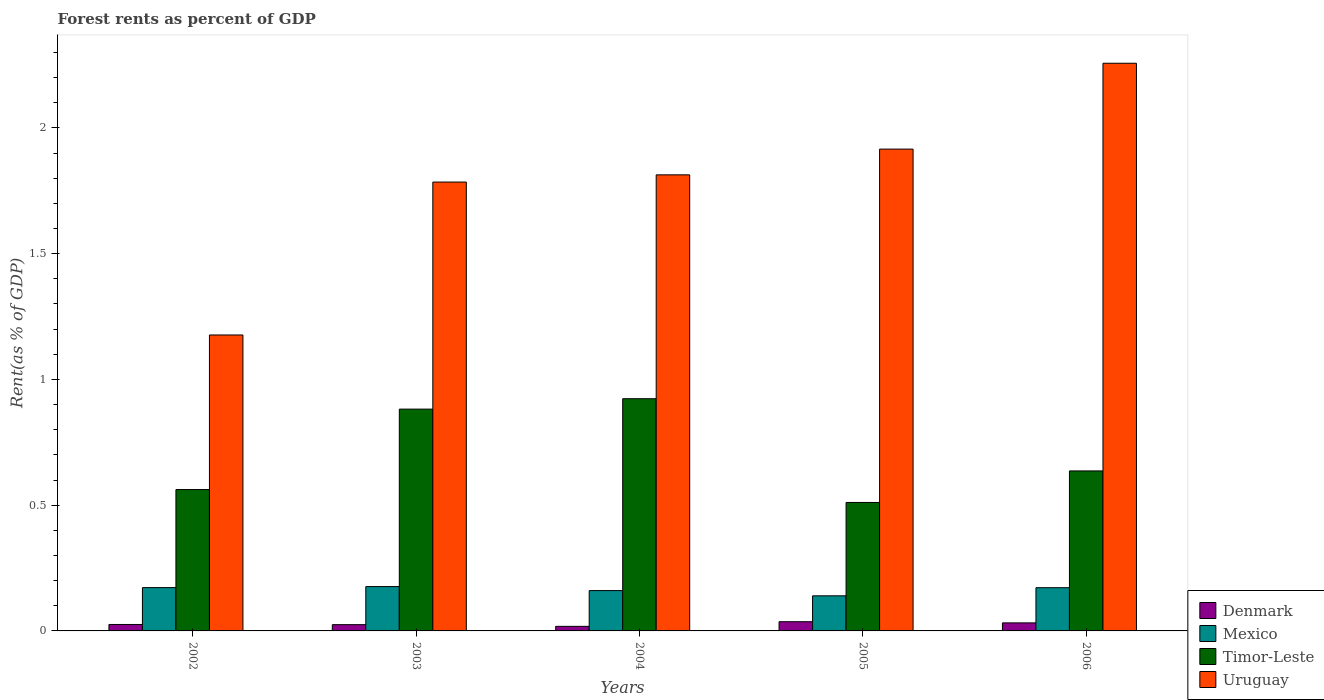How many bars are there on the 3rd tick from the left?
Give a very brief answer. 4. In how many cases, is the number of bars for a given year not equal to the number of legend labels?
Provide a short and direct response. 0. What is the forest rent in Denmark in 2004?
Offer a terse response. 0.02. Across all years, what is the maximum forest rent in Mexico?
Your answer should be very brief. 0.18. Across all years, what is the minimum forest rent in Timor-Leste?
Your answer should be compact. 0.51. In which year was the forest rent in Mexico maximum?
Offer a terse response. 2003. In which year was the forest rent in Denmark minimum?
Your answer should be compact. 2004. What is the total forest rent in Mexico in the graph?
Keep it short and to the point. 0.82. What is the difference between the forest rent in Mexico in 2004 and that in 2006?
Give a very brief answer. -0.01. What is the difference between the forest rent in Denmark in 2002 and the forest rent in Uruguay in 2004?
Make the answer very short. -1.79. What is the average forest rent in Mexico per year?
Give a very brief answer. 0.16. In the year 2006, what is the difference between the forest rent in Denmark and forest rent in Timor-Leste?
Provide a succinct answer. -0.6. What is the ratio of the forest rent in Mexico in 2003 to that in 2005?
Provide a short and direct response. 1.26. Is the forest rent in Timor-Leste in 2003 less than that in 2006?
Provide a succinct answer. No. Is the difference between the forest rent in Denmark in 2002 and 2005 greater than the difference between the forest rent in Timor-Leste in 2002 and 2005?
Your answer should be very brief. No. What is the difference between the highest and the second highest forest rent in Denmark?
Your answer should be compact. 0. What is the difference between the highest and the lowest forest rent in Mexico?
Your answer should be compact. 0.04. Is it the case that in every year, the sum of the forest rent in Timor-Leste and forest rent in Uruguay is greater than the sum of forest rent in Denmark and forest rent in Mexico?
Offer a terse response. Yes. What does the 1st bar from the left in 2004 represents?
Offer a very short reply. Denmark. What does the 2nd bar from the right in 2004 represents?
Ensure brevity in your answer.  Timor-Leste. How many bars are there?
Make the answer very short. 20. What is the difference between two consecutive major ticks on the Y-axis?
Make the answer very short. 0.5. Does the graph contain any zero values?
Provide a succinct answer. No. Where does the legend appear in the graph?
Your response must be concise. Bottom right. How are the legend labels stacked?
Offer a terse response. Vertical. What is the title of the graph?
Your response must be concise. Forest rents as percent of GDP. Does "Malawi" appear as one of the legend labels in the graph?
Give a very brief answer. No. What is the label or title of the Y-axis?
Your answer should be compact. Rent(as % of GDP). What is the Rent(as % of GDP) in Denmark in 2002?
Provide a succinct answer. 0.03. What is the Rent(as % of GDP) in Mexico in 2002?
Ensure brevity in your answer.  0.17. What is the Rent(as % of GDP) in Timor-Leste in 2002?
Provide a succinct answer. 0.56. What is the Rent(as % of GDP) in Uruguay in 2002?
Your answer should be very brief. 1.18. What is the Rent(as % of GDP) in Denmark in 2003?
Keep it short and to the point. 0.02. What is the Rent(as % of GDP) of Mexico in 2003?
Keep it short and to the point. 0.18. What is the Rent(as % of GDP) in Timor-Leste in 2003?
Your answer should be compact. 0.88. What is the Rent(as % of GDP) in Uruguay in 2003?
Give a very brief answer. 1.78. What is the Rent(as % of GDP) of Denmark in 2004?
Ensure brevity in your answer.  0.02. What is the Rent(as % of GDP) in Mexico in 2004?
Keep it short and to the point. 0.16. What is the Rent(as % of GDP) in Timor-Leste in 2004?
Keep it short and to the point. 0.92. What is the Rent(as % of GDP) of Uruguay in 2004?
Provide a succinct answer. 1.81. What is the Rent(as % of GDP) of Denmark in 2005?
Keep it short and to the point. 0.04. What is the Rent(as % of GDP) of Mexico in 2005?
Provide a short and direct response. 0.14. What is the Rent(as % of GDP) in Timor-Leste in 2005?
Give a very brief answer. 0.51. What is the Rent(as % of GDP) in Uruguay in 2005?
Offer a very short reply. 1.92. What is the Rent(as % of GDP) of Denmark in 2006?
Ensure brevity in your answer.  0.03. What is the Rent(as % of GDP) in Mexico in 2006?
Make the answer very short. 0.17. What is the Rent(as % of GDP) of Timor-Leste in 2006?
Your response must be concise. 0.64. What is the Rent(as % of GDP) in Uruguay in 2006?
Offer a very short reply. 2.26. Across all years, what is the maximum Rent(as % of GDP) in Denmark?
Ensure brevity in your answer.  0.04. Across all years, what is the maximum Rent(as % of GDP) in Mexico?
Offer a terse response. 0.18. Across all years, what is the maximum Rent(as % of GDP) in Timor-Leste?
Your answer should be very brief. 0.92. Across all years, what is the maximum Rent(as % of GDP) of Uruguay?
Give a very brief answer. 2.26. Across all years, what is the minimum Rent(as % of GDP) of Denmark?
Ensure brevity in your answer.  0.02. Across all years, what is the minimum Rent(as % of GDP) of Mexico?
Give a very brief answer. 0.14. Across all years, what is the minimum Rent(as % of GDP) in Timor-Leste?
Offer a very short reply. 0.51. Across all years, what is the minimum Rent(as % of GDP) of Uruguay?
Ensure brevity in your answer.  1.18. What is the total Rent(as % of GDP) of Denmark in the graph?
Offer a terse response. 0.14. What is the total Rent(as % of GDP) of Mexico in the graph?
Give a very brief answer. 0.82. What is the total Rent(as % of GDP) in Timor-Leste in the graph?
Give a very brief answer. 3.51. What is the total Rent(as % of GDP) in Uruguay in the graph?
Offer a very short reply. 8.95. What is the difference between the Rent(as % of GDP) of Denmark in 2002 and that in 2003?
Provide a short and direct response. 0. What is the difference between the Rent(as % of GDP) in Mexico in 2002 and that in 2003?
Ensure brevity in your answer.  -0. What is the difference between the Rent(as % of GDP) of Timor-Leste in 2002 and that in 2003?
Keep it short and to the point. -0.32. What is the difference between the Rent(as % of GDP) in Uruguay in 2002 and that in 2003?
Ensure brevity in your answer.  -0.61. What is the difference between the Rent(as % of GDP) of Denmark in 2002 and that in 2004?
Ensure brevity in your answer.  0.01. What is the difference between the Rent(as % of GDP) in Mexico in 2002 and that in 2004?
Your answer should be very brief. 0.01. What is the difference between the Rent(as % of GDP) of Timor-Leste in 2002 and that in 2004?
Ensure brevity in your answer.  -0.36. What is the difference between the Rent(as % of GDP) of Uruguay in 2002 and that in 2004?
Offer a very short reply. -0.64. What is the difference between the Rent(as % of GDP) in Denmark in 2002 and that in 2005?
Your response must be concise. -0.01. What is the difference between the Rent(as % of GDP) of Mexico in 2002 and that in 2005?
Offer a terse response. 0.03. What is the difference between the Rent(as % of GDP) of Timor-Leste in 2002 and that in 2005?
Make the answer very short. 0.05. What is the difference between the Rent(as % of GDP) of Uruguay in 2002 and that in 2005?
Offer a terse response. -0.74. What is the difference between the Rent(as % of GDP) of Denmark in 2002 and that in 2006?
Provide a succinct answer. -0.01. What is the difference between the Rent(as % of GDP) of Mexico in 2002 and that in 2006?
Provide a succinct answer. 0. What is the difference between the Rent(as % of GDP) in Timor-Leste in 2002 and that in 2006?
Your response must be concise. -0.07. What is the difference between the Rent(as % of GDP) of Uruguay in 2002 and that in 2006?
Offer a terse response. -1.08. What is the difference between the Rent(as % of GDP) of Denmark in 2003 and that in 2004?
Provide a short and direct response. 0.01. What is the difference between the Rent(as % of GDP) in Mexico in 2003 and that in 2004?
Provide a short and direct response. 0.02. What is the difference between the Rent(as % of GDP) of Timor-Leste in 2003 and that in 2004?
Your response must be concise. -0.04. What is the difference between the Rent(as % of GDP) of Uruguay in 2003 and that in 2004?
Provide a short and direct response. -0.03. What is the difference between the Rent(as % of GDP) of Denmark in 2003 and that in 2005?
Provide a succinct answer. -0.01. What is the difference between the Rent(as % of GDP) of Mexico in 2003 and that in 2005?
Offer a very short reply. 0.04. What is the difference between the Rent(as % of GDP) of Timor-Leste in 2003 and that in 2005?
Your response must be concise. 0.37. What is the difference between the Rent(as % of GDP) of Uruguay in 2003 and that in 2005?
Make the answer very short. -0.13. What is the difference between the Rent(as % of GDP) in Denmark in 2003 and that in 2006?
Offer a terse response. -0.01. What is the difference between the Rent(as % of GDP) in Mexico in 2003 and that in 2006?
Give a very brief answer. 0. What is the difference between the Rent(as % of GDP) of Timor-Leste in 2003 and that in 2006?
Your response must be concise. 0.25. What is the difference between the Rent(as % of GDP) of Uruguay in 2003 and that in 2006?
Provide a succinct answer. -0.47. What is the difference between the Rent(as % of GDP) of Denmark in 2004 and that in 2005?
Ensure brevity in your answer.  -0.02. What is the difference between the Rent(as % of GDP) of Mexico in 2004 and that in 2005?
Provide a short and direct response. 0.02. What is the difference between the Rent(as % of GDP) of Timor-Leste in 2004 and that in 2005?
Offer a very short reply. 0.41. What is the difference between the Rent(as % of GDP) of Uruguay in 2004 and that in 2005?
Offer a terse response. -0.1. What is the difference between the Rent(as % of GDP) of Denmark in 2004 and that in 2006?
Your answer should be compact. -0.01. What is the difference between the Rent(as % of GDP) in Mexico in 2004 and that in 2006?
Ensure brevity in your answer.  -0.01. What is the difference between the Rent(as % of GDP) in Timor-Leste in 2004 and that in 2006?
Give a very brief answer. 0.29. What is the difference between the Rent(as % of GDP) in Uruguay in 2004 and that in 2006?
Keep it short and to the point. -0.44. What is the difference between the Rent(as % of GDP) in Denmark in 2005 and that in 2006?
Offer a very short reply. 0. What is the difference between the Rent(as % of GDP) of Mexico in 2005 and that in 2006?
Offer a terse response. -0.03. What is the difference between the Rent(as % of GDP) of Timor-Leste in 2005 and that in 2006?
Your answer should be compact. -0.13. What is the difference between the Rent(as % of GDP) of Uruguay in 2005 and that in 2006?
Provide a succinct answer. -0.34. What is the difference between the Rent(as % of GDP) in Denmark in 2002 and the Rent(as % of GDP) in Mexico in 2003?
Ensure brevity in your answer.  -0.15. What is the difference between the Rent(as % of GDP) of Denmark in 2002 and the Rent(as % of GDP) of Timor-Leste in 2003?
Your answer should be very brief. -0.86. What is the difference between the Rent(as % of GDP) in Denmark in 2002 and the Rent(as % of GDP) in Uruguay in 2003?
Offer a terse response. -1.76. What is the difference between the Rent(as % of GDP) in Mexico in 2002 and the Rent(as % of GDP) in Timor-Leste in 2003?
Provide a short and direct response. -0.71. What is the difference between the Rent(as % of GDP) of Mexico in 2002 and the Rent(as % of GDP) of Uruguay in 2003?
Give a very brief answer. -1.61. What is the difference between the Rent(as % of GDP) of Timor-Leste in 2002 and the Rent(as % of GDP) of Uruguay in 2003?
Provide a short and direct response. -1.22. What is the difference between the Rent(as % of GDP) in Denmark in 2002 and the Rent(as % of GDP) in Mexico in 2004?
Your response must be concise. -0.13. What is the difference between the Rent(as % of GDP) of Denmark in 2002 and the Rent(as % of GDP) of Timor-Leste in 2004?
Offer a very short reply. -0.9. What is the difference between the Rent(as % of GDP) of Denmark in 2002 and the Rent(as % of GDP) of Uruguay in 2004?
Make the answer very short. -1.79. What is the difference between the Rent(as % of GDP) in Mexico in 2002 and the Rent(as % of GDP) in Timor-Leste in 2004?
Keep it short and to the point. -0.75. What is the difference between the Rent(as % of GDP) of Mexico in 2002 and the Rent(as % of GDP) of Uruguay in 2004?
Offer a very short reply. -1.64. What is the difference between the Rent(as % of GDP) in Timor-Leste in 2002 and the Rent(as % of GDP) in Uruguay in 2004?
Provide a short and direct response. -1.25. What is the difference between the Rent(as % of GDP) in Denmark in 2002 and the Rent(as % of GDP) in Mexico in 2005?
Your answer should be compact. -0.11. What is the difference between the Rent(as % of GDP) in Denmark in 2002 and the Rent(as % of GDP) in Timor-Leste in 2005?
Offer a very short reply. -0.49. What is the difference between the Rent(as % of GDP) of Denmark in 2002 and the Rent(as % of GDP) of Uruguay in 2005?
Ensure brevity in your answer.  -1.89. What is the difference between the Rent(as % of GDP) in Mexico in 2002 and the Rent(as % of GDP) in Timor-Leste in 2005?
Provide a succinct answer. -0.34. What is the difference between the Rent(as % of GDP) in Mexico in 2002 and the Rent(as % of GDP) in Uruguay in 2005?
Give a very brief answer. -1.74. What is the difference between the Rent(as % of GDP) of Timor-Leste in 2002 and the Rent(as % of GDP) of Uruguay in 2005?
Offer a terse response. -1.35. What is the difference between the Rent(as % of GDP) in Denmark in 2002 and the Rent(as % of GDP) in Mexico in 2006?
Offer a very short reply. -0.15. What is the difference between the Rent(as % of GDP) of Denmark in 2002 and the Rent(as % of GDP) of Timor-Leste in 2006?
Your answer should be very brief. -0.61. What is the difference between the Rent(as % of GDP) of Denmark in 2002 and the Rent(as % of GDP) of Uruguay in 2006?
Give a very brief answer. -2.23. What is the difference between the Rent(as % of GDP) of Mexico in 2002 and the Rent(as % of GDP) of Timor-Leste in 2006?
Give a very brief answer. -0.46. What is the difference between the Rent(as % of GDP) in Mexico in 2002 and the Rent(as % of GDP) in Uruguay in 2006?
Ensure brevity in your answer.  -2.08. What is the difference between the Rent(as % of GDP) in Timor-Leste in 2002 and the Rent(as % of GDP) in Uruguay in 2006?
Offer a terse response. -1.7. What is the difference between the Rent(as % of GDP) in Denmark in 2003 and the Rent(as % of GDP) in Mexico in 2004?
Your answer should be very brief. -0.14. What is the difference between the Rent(as % of GDP) in Denmark in 2003 and the Rent(as % of GDP) in Timor-Leste in 2004?
Provide a short and direct response. -0.9. What is the difference between the Rent(as % of GDP) in Denmark in 2003 and the Rent(as % of GDP) in Uruguay in 2004?
Your answer should be compact. -1.79. What is the difference between the Rent(as % of GDP) of Mexico in 2003 and the Rent(as % of GDP) of Timor-Leste in 2004?
Make the answer very short. -0.75. What is the difference between the Rent(as % of GDP) in Mexico in 2003 and the Rent(as % of GDP) in Uruguay in 2004?
Provide a succinct answer. -1.64. What is the difference between the Rent(as % of GDP) in Timor-Leste in 2003 and the Rent(as % of GDP) in Uruguay in 2004?
Offer a very short reply. -0.93. What is the difference between the Rent(as % of GDP) of Denmark in 2003 and the Rent(as % of GDP) of Mexico in 2005?
Keep it short and to the point. -0.11. What is the difference between the Rent(as % of GDP) of Denmark in 2003 and the Rent(as % of GDP) of Timor-Leste in 2005?
Your response must be concise. -0.49. What is the difference between the Rent(as % of GDP) of Denmark in 2003 and the Rent(as % of GDP) of Uruguay in 2005?
Your answer should be compact. -1.89. What is the difference between the Rent(as % of GDP) in Mexico in 2003 and the Rent(as % of GDP) in Timor-Leste in 2005?
Your answer should be compact. -0.33. What is the difference between the Rent(as % of GDP) in Mexico in 2003 and the Rent(as % of GDP) in Uruguay in 2005?
Offer a terse response. -1.74. What is the difference between the Rent(as % of GDP) of Timor-Leste in 2003 and the Rent(as % of GDP) of Uruguay in 2005?
Your answer should be very brief. -1.03. What is the difference between the Rent(as % of GDP) in Denmark in 2003 and the Rent(as % of GDP) in Mexico in 2006?
Offer a very short reply. -0.15. What is the difference between the Rent(as % of GDP) of Denmark in 2003 and the Rent(as % of GDP) of Timor-Leste in 2006?
Provide a short and direct response. -0.61. What is the difference between the Rent(as % of GDP) of Denmark in 2003 and the Rent(as % of GDP) of Uruguay in 2006?
Your answer should be very brief. -2.23. What is the difference between the Rent(as % of GDP) of Mexico in 2003 and the Rent(as % of GDP) of Timor-Leste in 2006?
Offer a very short reply. -0.46. What is the difference between the Rent(as % of GDP) in Mexico in 2003 and the Rent(as % of GDP) in Uruguay in 2006?
Your answer should be compact. -2.08. What is the difference between the Rent(as % of GDP) in Timor-Leste in 2003 and the Rent(as % of GDP) in Uruguay in 2006?
Provide a succinct answer. -1.38. What is the difference between the Rent(as % of GDP) of Denmark in 2004 and the Rent(as % of GDP) of Mexico in 2005?
Provide a succinct answer. -0.12. What is the difference between the Rent(as % of GDP) of Denmark in 2004 and the Rent(as % of GDP) of Timor-Leste in 2005?
Keep it short and to the point. -0.49. What is the difference between the Rent(as % of GDP) in Denmark in 2004 and the Rent(as % of GDP) in Uruguay in 2005?
Provide a short and direct response. -1.9. What is the difference between the Rent(as % of GDP) of Mexico in 2004 and the Rent(as % of GDP) of Timor-Leste in 2005?
Offer a very short reply. -0.35. What is the difference between the Rent(as % of GDP) of Mexico in 2004 and the Rent(as % of GDP) of Uruguay in 2005?
Your response must be concise. -1.76. What is the difference between the Rent(as % of GDP) in Timor-Leste in 2004 and the Rent(as % of GDP) in Uruguay in 2005?
Keep it short and to the point. -0.99. What is the difference between the Rent(as % of GDP) of Denmark in 2004 and the Rent(as % of GDP) of Mexico in 2006?
Keep it short and to the point. -0.15. What is the difference between the Rent(as % of GDP) in Denmark in 2004 and the Rent(as % of GDP) in Timor-Leste in 2006?
Offer a terse response. -0.62. What is the difference between the Rent(as % of GDP) of Denmark in 2004 and the Rent(as % of GDP) of Uruguay in 2006?
Give a very brief answer. -2.24. What is the difference between the Rent(as % of GDP) in Mexico in 2004 and the Rent(as % of GDP) in Timor-Leste in 2006?
Your answer should be very brief. -0.48. What is the difference between the Rent(as % of GDP) of Mexico in 2004 and the Rent(as % of GDP) of Uruguay in 2006?
Keep it short and to the point. -2.1. What is the difference between the Rent(as % of GDP) in Timor-Leste in 2004 and the Rent(as % of GDP) in Uruguay in 2006?
Give a very brief answer. -1.33. What is the difference between the Rent(as % of GDP) of Denmark in 2005 and the Rent(as % of GDP) of Mexico in 2006?
Your response must be concise. -0.14. What is the difference between the Rent(as % of GDP) in Denmark in 2005 and the Rent(as % of GDP) in Timor-Leste in 2006?
Your answer should be compact. -0.6. What is the difference between the Rent(as % of GDP) in Denmark in 2005 and the Rent(as % of GDP) in Uruguay in 2006?
Make the answer very short. -2.22. What is the difference between the Rent(as % of GDP) of Mexico in 2005 and the Rent(as % of GDP) of Timor-Leste in 2006?
Offer a terse response. -0.5. What is the difference between the Rent(as % of GDP) of Mexico in 2005 and the Rent(as % of GDP) of Uruguay in 2006?
Provide a succinct answer. -2.12. What is the difference between the Rent(as % of GDP) of Timor-Leste in 2005 and the Rent(as % of GDP) of Uruguay in 2006?
Provide a short and direct response. -1.75. What is the average Rent(as % of GDP) of Denmark per year?
Offer a very short reply. 0.03. What is the average Rent(as % of GDP) of Mexico per year?
Give a very brief answer. 0.16. What is the average Rent(as % of GDP) in Timor-Leste per year?
Provide a succinct answer. 0.7. What is the average Rent(as % of GDP) of Uruguay per year?
Your answer should be compact. 1.79. In the year 2002, what is the difference between the Rent(as % of GDP) of Denmark and Rent(as % of GDP) of Mexico?
Ensure brevity in your answer.  -0.15. In the year 2002, what is the difference between the Rent(as % of GDP) of Denmark and Rent(as % of GDP) of Timor-Leste?
Keep it short and to the point. -0.54. In the year 2002, what is the difference between the Rent(as % of GDP) in Denmark and Rent(as % of GDP) in Uruguay?
Offer a very short reply. -1.15. In the year 2002, what is the difference between the Rent(as % of GDP) of Mexico and Rent(as % of GDP) of Timor-Leste?
Offer a terse response. -0.39. In the year 2002, what is the difference between the Rent(as % of GDP) of Mexico and Rent(as % of GDP) of Uruguay?
Provide a short and direct response. -1. In the year 2002, what is the difference between the Rent(as % of GDP) in Timor-Leste and Rent(as % of GDP) in Uruguay?
Your answer should be very brief. -0.61. In the year 2003, what is the difference between the Rent(as % of GDP) of Denmark and Rent(as % of GDP) of Mexico?
Give a very brief answer. -0.15. In the year 2003, what is the difference between the Rent(as % of GDP) in Denmark and Rent(as % of GDP) in Timor-Leste?
Provide a succinct answer. -0.86. In the year 2003, what is the difference between the Rent(as % of GDP) in Denmark and Rent(as % of GDP) in Uruguay?
Provide a succinct answer. -1.76. In the year 2003, what is the difference between the Rent(as % of GDP) of Mexico and Rent(as % of GDP) of Timor-Leste?
Give a very brief answer. -0.71. In the year 2003, what is the difference between the Rent(as % of GDP) of Mexico and Rent(as % of GDP) of Uruguay?
Offer a very short reply. -1.61. In the year 2003, what is the difference between the Rent(as % of GDP) of Timor-Leste and Rent(as % of GDP) of Uruguay?
Provide a short and direct response. -0.9. In the year 2004, what is the difference between the Rent(as % of GDP) in Denmark and Rent(as % of GDP) in Mexico?
Your answer should be compact. -0.14. In the year 2004, what is the difference between the Rent(as % of GDP) of Denmark and Rent(as % of GDP) of Timor-Leste?
Offer a very short reply. -0.91. In the year 2004, what is the difference between the Rent(as % of GDP) of Denmark and Rent(as % of GDP) of Uruguay?
Your response must be concise. -1.8. In the year 2004, what is the difference between the Rent(as % of GDP) in Mexico and Rent(as % of GDP) in Timor-Leste?
Provide a succinct answer. -0.76. In the year 2004, what is the difference between the Rent(as % of GDP) of Mexico and Rent(as % of GDP) of Uruguay?
Ensure brevity in your answer.  -1.65. In the year 2004, what is the difference between the Rent(as % of GDP) of Timor-Leste and Rent(as % of GDP) of Uruguay?
Offer a very short reply. -0.89. In the year 2005, what is the difference between the Rent(as % of GDP) of Denmark and Rent(as % of GDP) of Mexico?
Your answer should be compact. -0.1. In the year 2005, what is the difference between the Rent(as % of GDP) of Denmark and Rent(as % of GDP) of Timor-Leste?
Offer a terse response. -0.47. In the year 2005, what is the difference between the Rent(as % of GDP) in Denmark and Rent(as % of GDP) in Uruguay?
Keep it short and to the point. -1.88. In the year 2005, what is the difference between the Rent(as % of GDP) in Mexico and Rent(as % of GDP) in Timor-Leste?
Make the answer very short. -0.37. In the year 2005, what is the difference between the Rent(as % of GDP) in Mexico and Rent(as % of GDP) in Uruguay?
Provide a short and direct response. -1.78. In the year 2005, what is the difference between the Rent(as % of GDP) of Timor-Leste and Rent(as % of GDP) of Uruguay?
Your response must be concise. -1.41. In the year 2006, what is the difference between the Rent(as % of GDP) in Denmark and Rent(as % of GDP) in Mexico?
Offer a terse response. -0.14. In the year 2006, what is the difference between the Rent(as % of GDP) in Denmark and Rent(as % of GDP) in Timor-Leste?
Give a very brief answer. -0.6. In the year 2006, what is the difference between the Rent(as % of GDP) of Denmark and Rent(as % of GDP) of Uruguay?
Give a very brief answer. -2.23. In the year 2006, what is the difference between the Rent(as % of GDP) of Mexico and Rent(as % of GDP) of Timor-Leste?
Your answer should be compact. -0.46. In the year 2006, what is the difference between the Rent(as % of GDP) of Mexico and Rent(as % of GDP) of Uruguay?
Keep it short and to the point. -2.09. In the year 2006, what is the difference between the Rent(as % of GDP) in Timor-Leste and Rent(as % of GDP) in Uruguay?
Your response must be concise. -1.62. What is the ratio of the Rent(as % of GDP) in Denmark in 2002 to that in 2003?
Ensure brevity in your answer.  1.03. What is the ratio of the Rent(as % of GDP) of Mexico in 2002 to that in 2003?
Ensure brevity in your answer.  0.98. What is the ratio of the Rent(as % of GDP) in Timor-Leste in 2002 to that in 2003?
Give a very brief answer. 0.64. What is the ratio of the Rent(as % of GDP) in Uruguay in 2002 to that in 2003?
Provide a succinct answer. 0.66. What is the ratio of the Rent(as % of GDP) of Denmark in 2002 to that in 2004?
Your response must be concise. 1.41. What is the ratio of the Rent(as % of GDP) in Mexico in 2002 to that in 2004?
Provide a short and direct response. 1.07. What is the ratio of the Rent(as % of GDP) of Timor-Leste in 2002 to that in 2004?
Provide a short and direct response. 0.61. What is the ratio of the Rent(as % of GDP) of Uruguay in 2002 to that in 2004?
Your answer should be compact. 0.65. What is the ratio of the Rent(as % of GDP) of Denmark in 2002 to that in 2005?
Your response must be concise. 0.7. What is the ratio of the Rent(as % of GDP) in Mexico in 2002 to that in 2005?
Your answer should be very brief. 1.23. What is the ratio of the Rent(as % of GDP) in Timor-Leste in 2002 to that in 2005?
Your answer should be compact. 1.1. What is the ratio of the Rent(as % of GDP) in Uruguay in 2002 to that in 2005?
Your response must be concise. 0.61. What is the ratio of the Rent(as % of GDP) of Denmark in 2002 to that in 2006?
Your answer should be very brief. 0.8. What is the ratio of the Rent(as % of GDP) of Mexico in 2002 to that in 2006?
Your answer should be very brief. 1. What is the ratio of the Rent(as % of GDP) of Timor-Leste in 2002 to that in 2006?
Provide a succinct answer. 0.88. What is the ratio of the Rent(as % of GDP) of Uruguay in 2002 to that in 2006?
Keep it short and to the point. 0.52. What is the ratio of the Rent(as % of GDP) of Denmark in 2003 to that in 2004?
Make the answer very short. 1.37. What is the ratio of the Rent(as % of GDP) in Mexico in 2003 to that in 2004?
Your answer should be very brief. 1.1. What is the ratio of the Rent(as % of GDP) of Timor-Leste in 2003 to that in 2004?
Your response must be concise. 0.96. What is the ratio of the Rent(as % of GDP) in Uruguay in 2003 to that in 2004?
Your answer should be very brief. 0.98. What is the ratio of the Rent(as % of GDP) in Denmark in 2003 to that in 2005?
Provide a short and direct response. 0.68. What is the ratio of the Rent(as % of GDP) in Mexico in 2003 to that in 2005?
Your response must be concise. 1.26. What is the ratio of the Rent(as % of GDP) of Timor-Leste in 2003 to that in 2005?
Ensure brevity in your answer.  1.73. What is the ratio of the Rent(as % of GDP) in Uruguay in 2003 to that in 2005?
Your answer should be very brief. 0.93. What is the ratio of the Rent(as % of GDP) in Denmark in 2003 to that in 2006?
Your response must be concise. 0.78. What is the ratio of the Rent(as % of GDP) in Mexico in 2003 to that in 2006?
Your answer should be very brief. 1.03. What is the ratio of the Rent(as % of GDP) in Timor-Leste in 2003 to that in 2006?
Give a very brief answer. 1.39. What is the ratio of the Rent(as % of GDP) in Uruguay in 2003 to that in 2006?
Give a very brief answer. 0.79. What is the ratio of the Rent(as % of GDP) of Denmark in 2004 to that in 2005?
Your answer should be very brief. 0.5. What is the ratio of the Rent(as % of GDP) in Mexico in 2004 to that in 2005?
Keep it short and to the point. 1.15. What is the ratio of the Rent(as % of GDP) of Timor-Leste in 2004 to that in 2005?
Provide a short and direct response. 1.81. What is the ratio of the Rent(as % of GDP) of Uruguay in 2004 to that in 2005?
Provide a short and direct response. 0.95. What is the ratio of the Rent(as % of GDP) of Denmark in 2004 to that in 2006?
Your answer should be very brief. 0.57. What is the ratio of the Rent(as % of GDP) of Mexico in 2004 to that in 2006?
Give a very brief answer. 0.93. What is the ratio of the Rent(as % of GDP) of Timor-Leste in 2004 to that in 2006?
Offer a very short reply. 1.45. What is the ratio of the Rent(as % of GDP) in Uruguay in 2004 to that in 2006?
Your response must be concise. 0.8. What is the ratio of the Rent(as % of GDP) in Denmark in 2005 to that in 2006?
Your answer should be compact. 1.15. What is the ratio of the Rent(as % of GDP) in Mexico in 2005 to that in 2006?
Your answer should be very brief. 0.81. What is the ratio of the Rent(as % of GDP) of Timor-Leste in 2005 to that in 2006?
Provide a short and direct response. 0.8. What is the ratio of the Rent(as % of GDP) in Uruguay in 2005 to that in 2006?
Your response must be concise. 0.85. What is the difference between the highest and the second highest Rent(as % of GDP) in Denmark?
Your answer should be compact. 0. What is the difference between the highest and the second highest Rent(as % of GDP) in Mexico?
Keep it short and to the point. 0. What is the difference between the highest and the second highest Rent(as % of GDP) of Timor-Leste?
Provide a short and direct response. 0.04. What is the difference between the highest and the second highest Rent(as % of GDP) of Uruguay?
Offer a terse response. 0.34. What is the difference between the highest and the lowest Rent(as % of GDP) of Denmark?
Provide a short and direct response. 0.02. What is the difference between the highest and the lowest Rent(as % of GDP) of Mexico?
Your response must be concise. 0.04. What is the difference between the highest and the lowest Rent(as % of GDP) of Timor-Leste?
Your answer should be very brief. 0.41. What is the difference between the highest and the lowest Rent(as % of GDP) of Uruguay?
Make the answer very short. 1.08. 